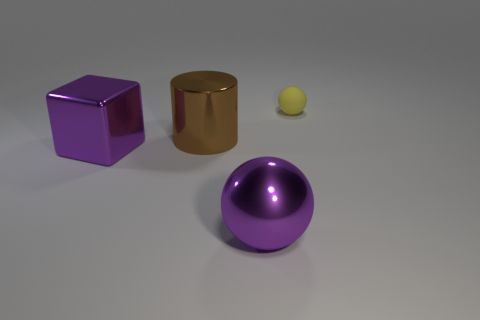Add 1 purple metal objects. How many objects exist? 5 Subtract all cylinders. How many objects are left? 3 Subtract all big brown objects. Subtract all purple metal things. How many objects are left? 1 Add 3 matte things. How many matte things are left? 4 Add 2 red metal things. How many red metal things exist? 2 Subtract 0 gray cylinders. How many objects are left? 4 